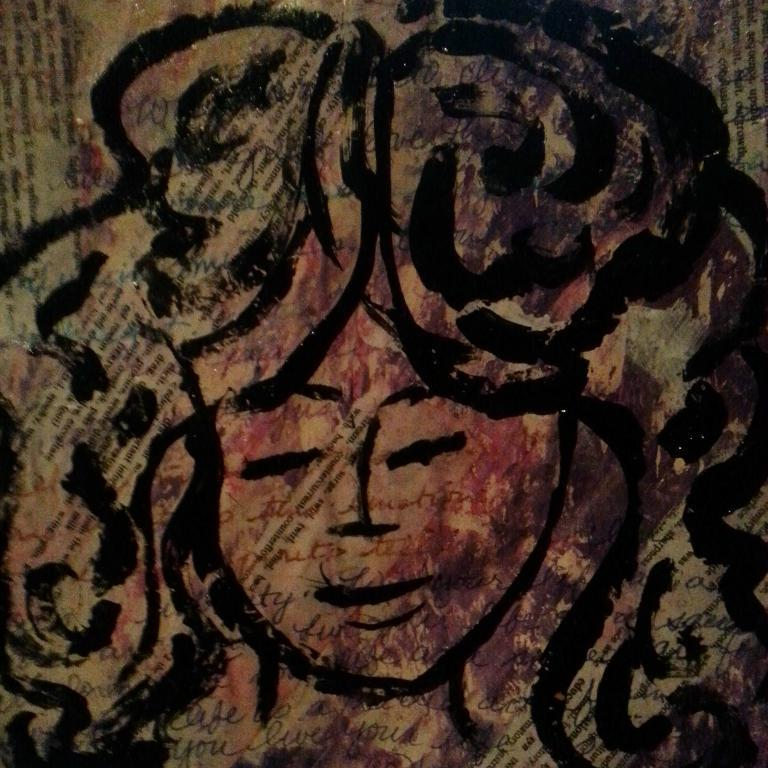What is depicted on the paper in the image? There is a painting of a girl on the paper. What else can be seen in the image besides the painting? There is text visible in the background of the image. What type of hall is visible in the image? There is no hall visible in the image; it only features a painting of a girl on paper and text in the background. 